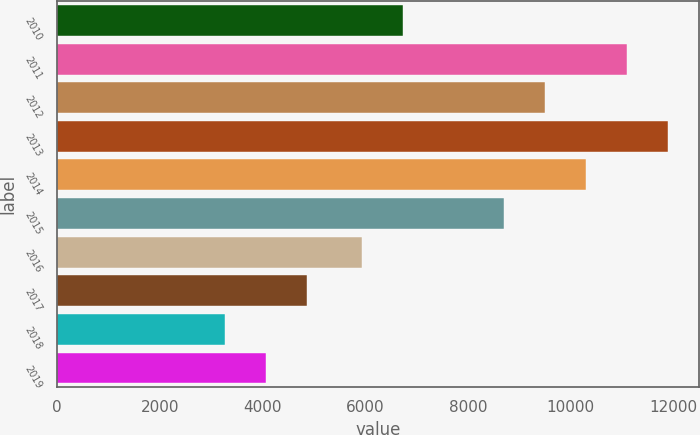Convert chart to OTSL. <chart><loc_0><loc_0><loc_500><loc_500><bar_chart><fcel>2010<fcel>2011<fcel>2012<fcel>2013<fcel>2014<fcel>2015<fcel>2016<fcel>2017<fcel>2018<fcel>2019<nl><fcel>6740.5<fcel>11097.5<fcel>9498.5<fcel>11897<fcel>10298<fcel>8699<fcel>5941<fcel>4872<fcel>3273<fcel>4072.5<nl></chart> 